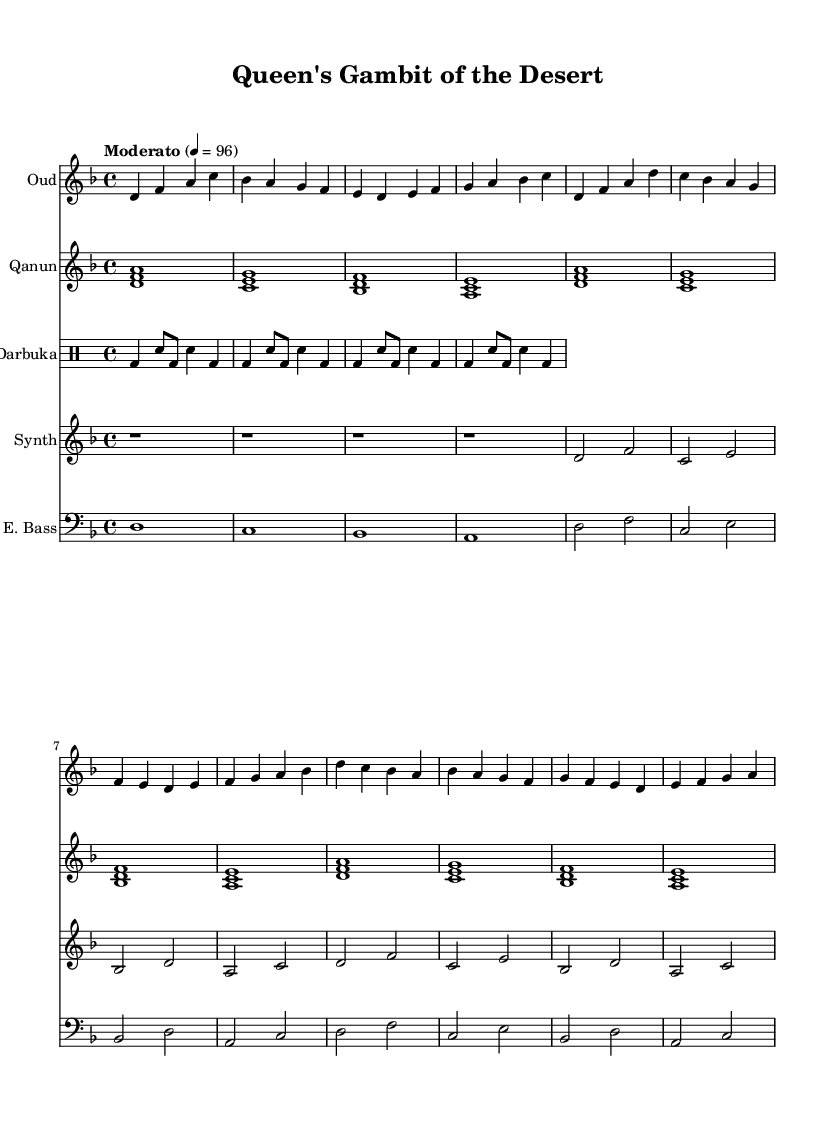What is the key signature of this music? The key signature is indicated by the presence of two flat symbols (B♭ and E♭) on the staff. This means the music is in the key of D minor, which uses these flats.
Answer: D minor What is the time signature of this music? The time signature appears at the beginning of the score, showing a "4/4" indicator that signifies four beats per measure, with a quarter note getting one beat.
Answer: 4/4 What is the tempo marking for this piece? The tempo marking is shown as "Moderato" followed by a metronome marking of "4 = 96," meaning the piece is to be played at a moderate speed of 96 beats per minute.
Answer: Moderato, 96 How many measures are in the introduction section? By counting the measures in the "Introduction" section of each staff (oud, qanun, etc.), we find there are four measures in total.
Answer: 4 Which instruments are included in the score? The score lists five instruments: Oud, Qanun, Darbuka, Synth, and Electric Bass. Each has its own staff, indicating they are featured in the piece.
Answer: Oud, Qanun, Darbuka, Synth, Electric Bass What type of drum is specified in this score? The drum part is indicated by the "Darbuka," a traditional percussion instrument commonly used in Middle Eastern music. The notation shows the specific drum sounds in the piece.
Answer: Darbuka In which section does the main groove occur? The main groove is represented in the "Darbuka" part, which shows consistent rhythmic patterns indicating its groove occurrence primarily in the introduction and the entire verse sections.
Answer: Main Groove in the verse 